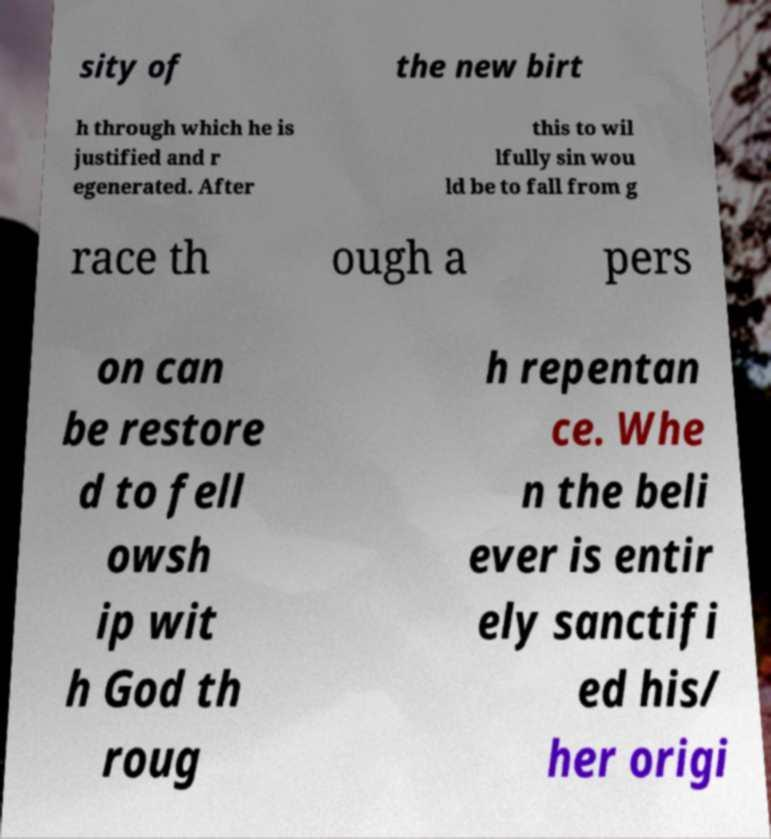What messages or text are displayed in this image? I need them in a readable, typed format. sity of the new birt h through which he is justified and r egenerated. After this to wil lfully sin wou ld be to fall from g race th ough a pers on can be restore d to fell owsh ip wit h God th roug h repentan ce. Whe n the beli ever is entir ely sanctifi ed his/ her origi 